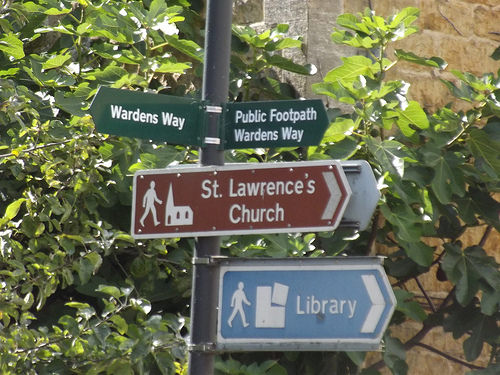<image>
Is there a street sign behind the plant? No. The street sign is not behind the plant. From this viewpoint, the street sign appears to be positioned elsewhere in the scene. 